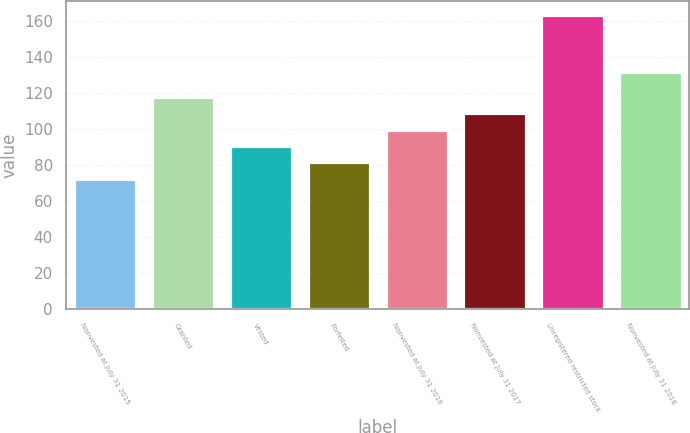<chart> <loc_0><loc_0><loc_500><loc_500><bar_chart><fcel>Nonvested at July 31 2015<fcel>Granted<fcel>Vested<fcel>Forfeited<fcel>Nonvested at July 31 2016<fcel>Nonvested at July 31 2017<fcel>Unregistered restricted stock<fcel>Nonvested at July 31 2018<nl><fcel>72.48<fcel>117.73<fcel>90.58<fcel>81.53<fcel>99.63<fcel>108.68<fcel>163<fcel>131.5<nl></chart> 